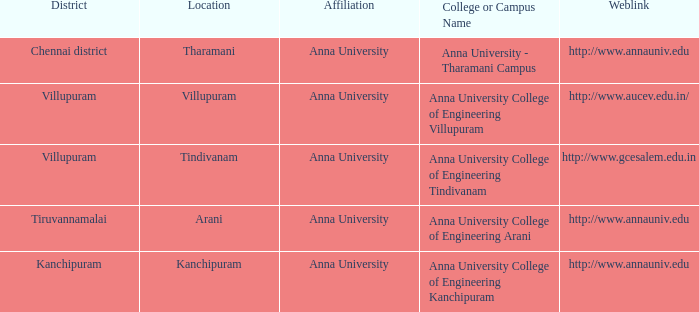What district is home to a college or campus known as anna university college of engineering kanchipuram? Kanchipuram. Could you parse the entire table? {'header': ['District', 'Location', 'Affiliation', 'College or Campus Name', 'Weblink'], 'rows': [['Chennai district', 'Tharamani', 'Anna University', 'Anna University - Tharamani Campus', 'http://www.annauniv.edu'], ['Villupuram', 'Villupuram', 'Anna University', 'Anna University College of Engineering Villupuram', 'http://www.aucev.edu.in/'], ['Villupuram', 'Tindivanam', 'Anna University', 'Anna University College of Engineering Tindivanam', 'http://www.gcesalem.edu.in'], ['Tiruvannamalai', 'Arani', 'Anna University', 'Anna University College of Engineering Arani', 'http://www.annauniv.edu'], ['Kanchipuram', 'Kanchipuram', 'Anna University', 'Anna University College of Engineering Kanchipuram', 'http://www.annauniv.edu']]} 